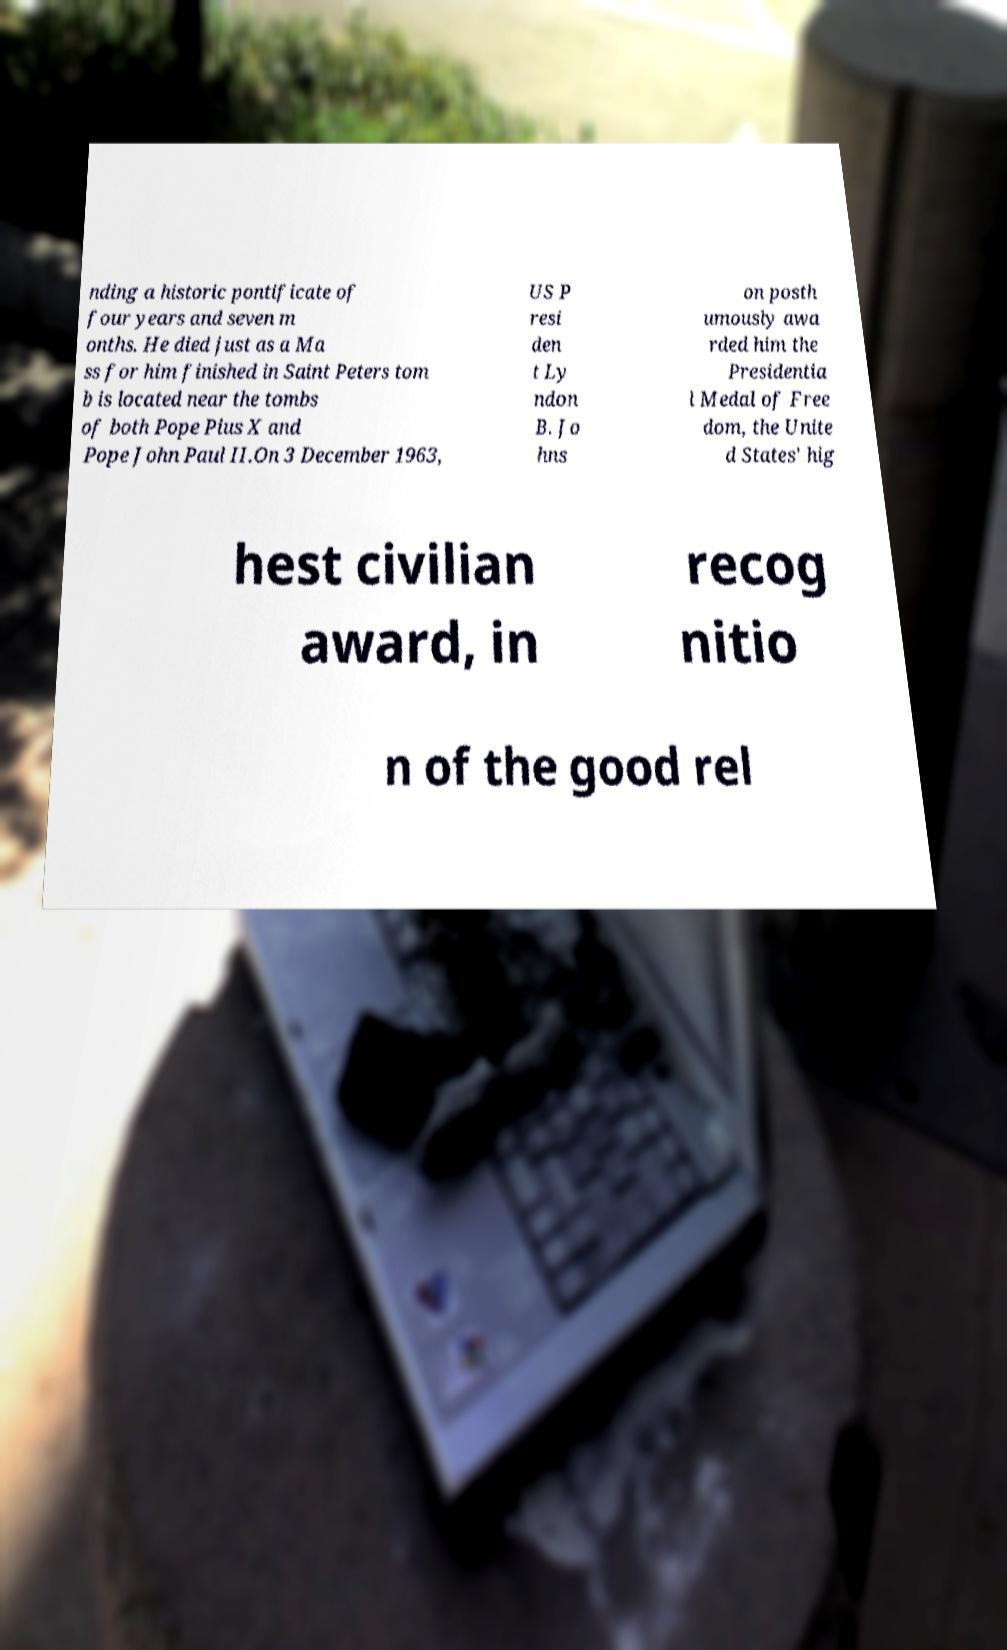Could you extract and type out the text from this image? nding a historic pontificate of four years and seven m onths. He died just as a Ma ss for him finished in Saint Peters tom b is located near the tombs of both Pope Pius X and Pope John Paul II.On 3 December 1963, US P resi den t Ly ndon B. Jo hns on posth umously awa rded him the Presidentia l Medal of Free dom, the Unite d States' hig hest civilian award, in recog nitio n of the good rel 